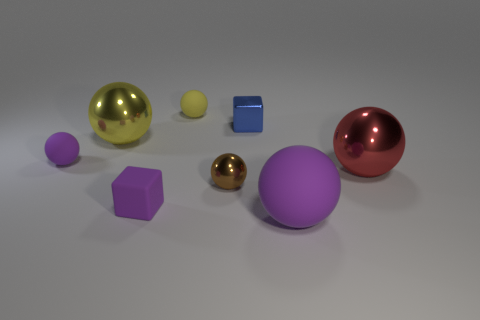Subtract all brown balls. How many balls are left? 5 Subtract all red metallic balls. How many balls are left? 5 Subtract all cyan spheres. Subtract all yellow blocks. How many spheres are left? 6 Add 1 small brown matte spheres. How many objects exist? 9 Subtract all blocks. How many objects are left? 6 Add 5 blocks. How many blocks are left? 7 Add 5 big yellow metallic balls. How many big yellow metallic balls exist? 6 Subtract 1 brown spheres. How many objects are left? 7 Subtract all yellow matte balls. Subtract all yellow spheres. How many objects are left? 5 